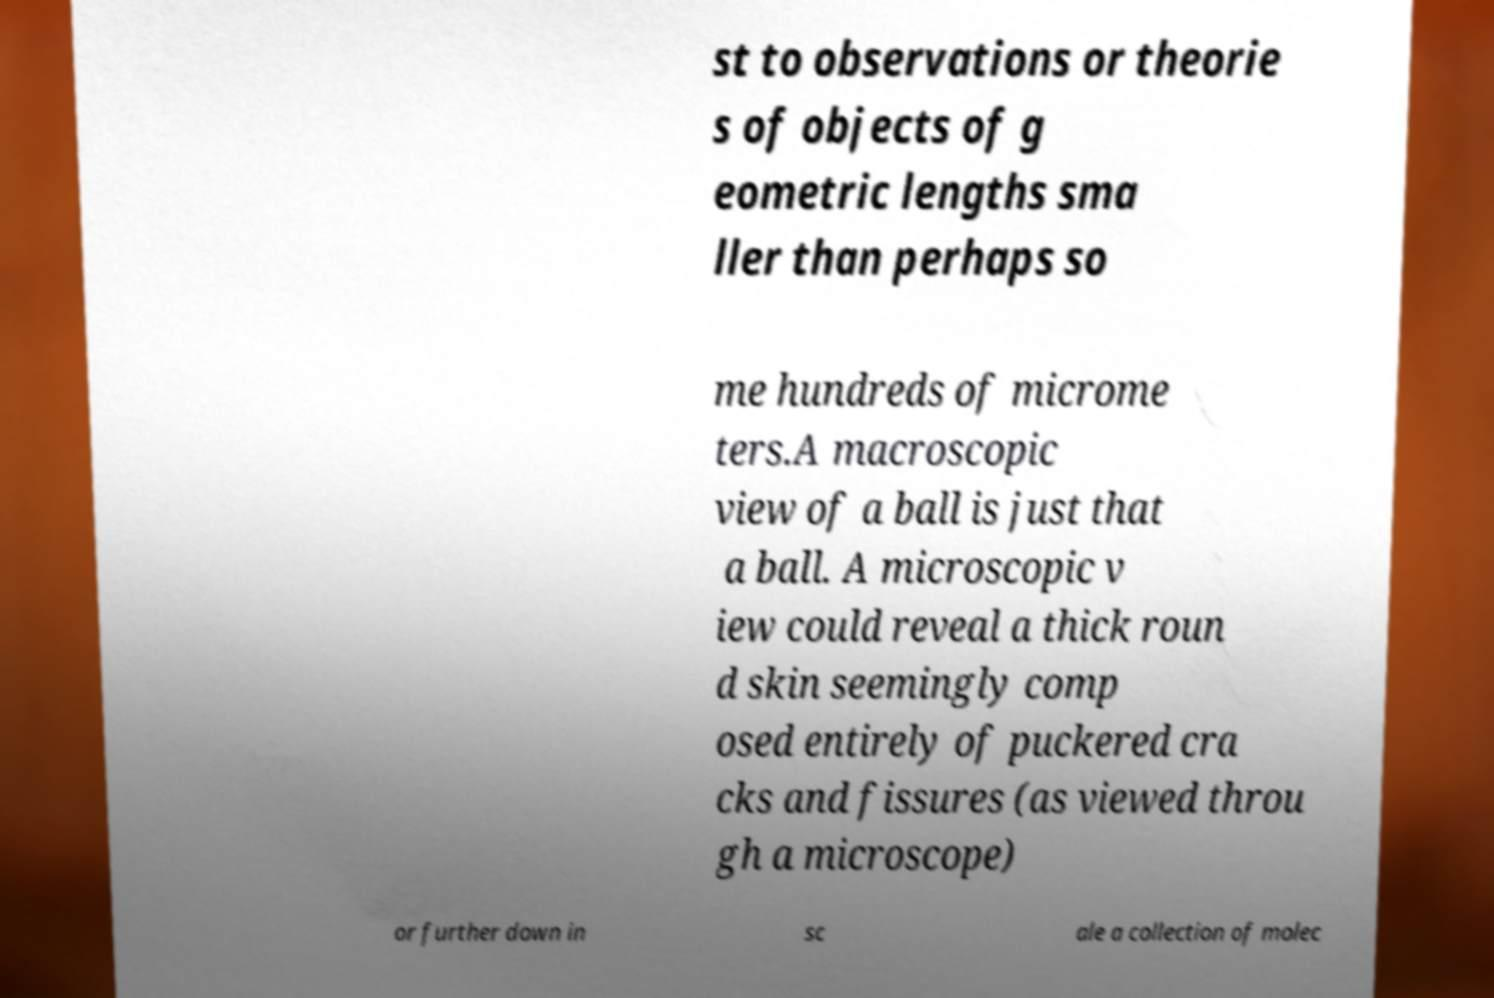There's text embedded in this image that I need extracted. Can you transcribe it verbatim? st to observations or theorie s of objects of g eometric lengths sma ller than perhaps so me hundreds of microme ters.A macroscopic view of a ball is just that a ball. A microscopic v iew could reveal a thick roun d skin seemingly comp osed entirely of puckered cra cks and fissures (as viewed throu gh a microscope) or further down in sc ale a collection of molec 